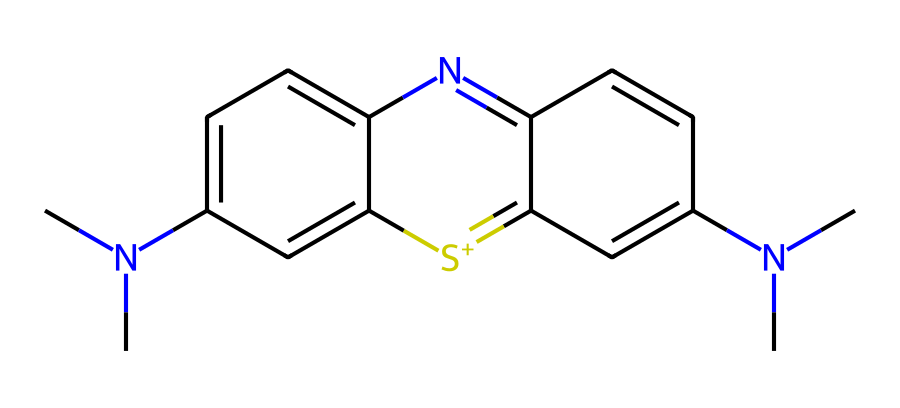How many nitrogen atoms are present in Methylene Blue? By examining the SMILES representation, we can identify that there are three nitrogen atoms present in the structure, each denoted by 'N.'
Answer: three What is the total number of carbon atoms in Methylene Blue? Counting the carbon atoms in the SMILES representation (denoted by 'C'), we find a total of 15 carbon atoms when we consider all the instances of 'C' in the structure.
Answer: fifteen What type of chemical compound is Methylene Blue classified as? Methylene Blue is a cationic dye due to its positive charge indicated by '[s+]' within the SMILES and the presence of nitrogen, which contributes to its basic character.
Answer: cationic dye How many fused rings are present in the structure of Methylene Blue? The structure exhibits two fused rings, which can be inferred from the 'c' and 'n' characters that represent the aromatic and nitrogen atoms, respectively, indicating a conjugated system.
Answer: two What functional groups are suggested by the SMILES notation of Methylene Blue? The SMILES reveals the presence of dimethylamino groups (indicated by 'CN(C)'), which are characteristic of indicators of quaternary ammonium compounds, suggesting functional properties of the dye.
Answer: dimethylamino How many sulfate groups are in Methylene Blue? The SMILES does not indicate the presence of any sulfate groups, as there are no instances of 'SO4' or similar representations in the structure.
Answer: zero What role does the positive charge play in the behavior of Methylene Blue? The positive charge, indicated by '[s+]', suggests Methylene Blue's ability to interact with negatively charged biomolecules, making it useful for biological applications such as a dye and potential medical treatments.
Answer: interaction with biomolecules 